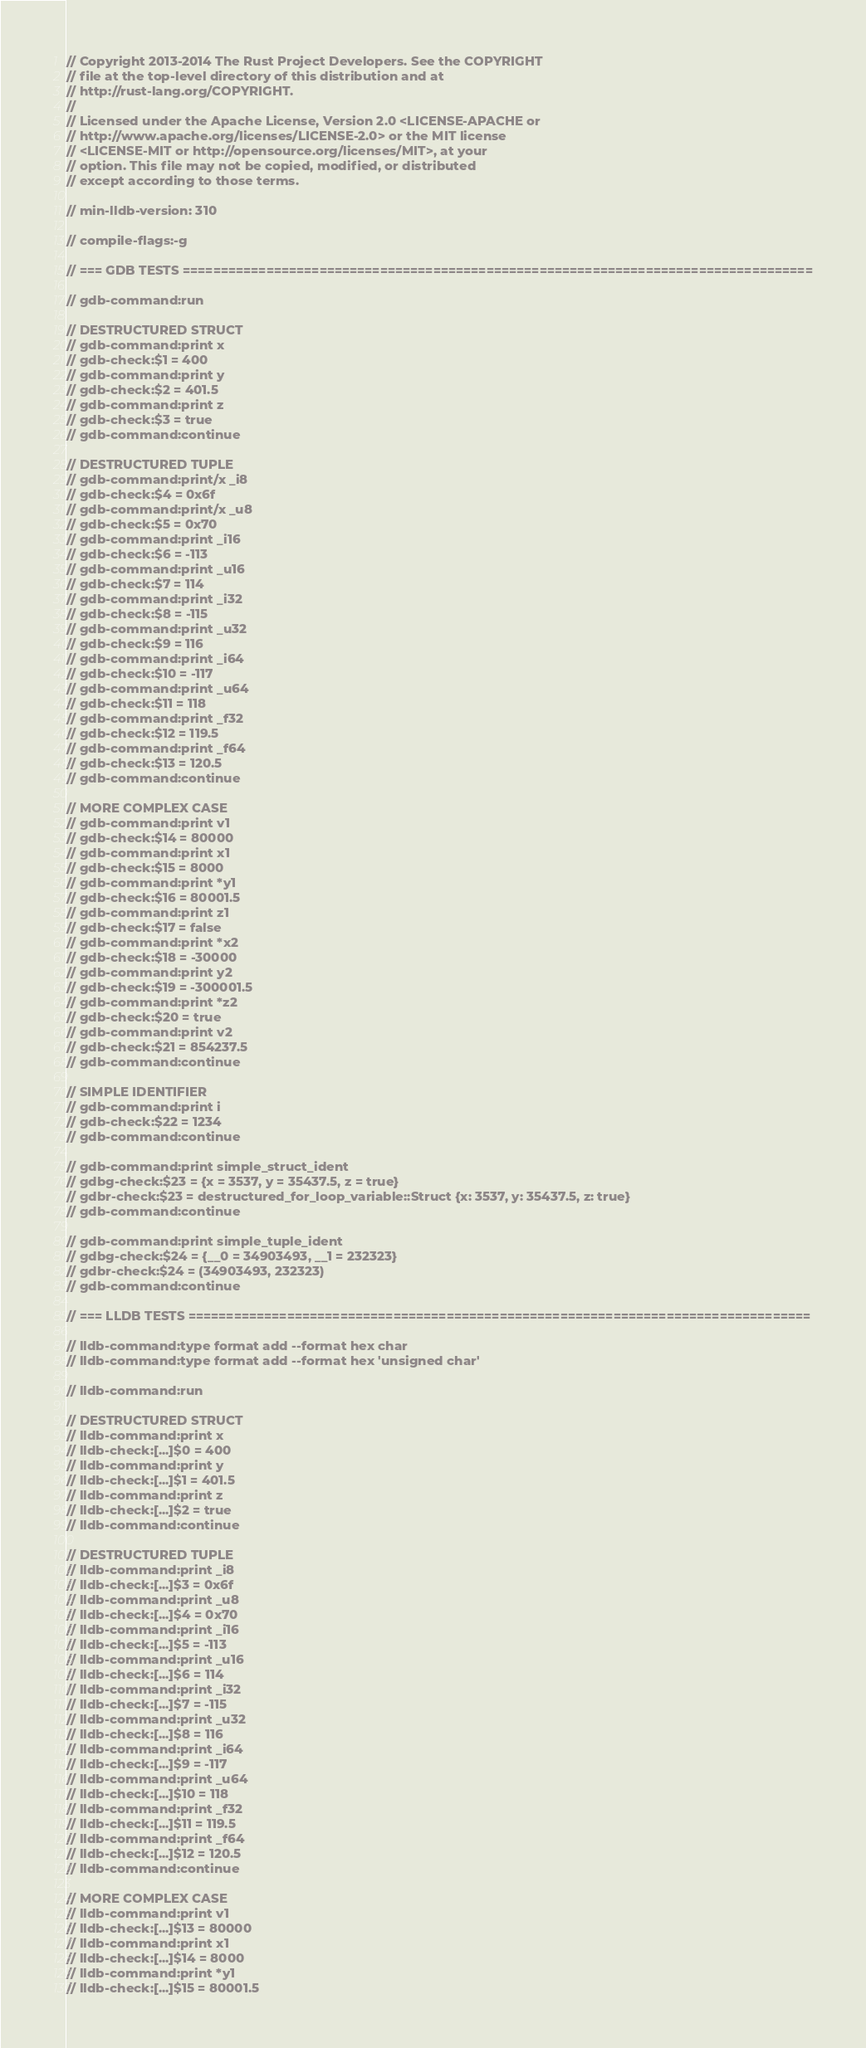Convert code to text. <code><loc_0><loc_0><loc_500><loc_500><_Rust_>// Copyright 2013-2014 The Rust Project Developers. See the COPYRIGHT
// file at the top-level directory of this distribution and at
// http://rust-lang.org/COPYRIGHT.
//
// Licensed under the Apache License, Version 2.0 <LICENSE-APACHE or
// http://www.apache.org/licenses/LICENSE-2.0> or the MIT license
// <LICENSE-MIT or http://opensource.org/licenses/MIT>, at your
// option. This file may not be copied, modified, or distributed
// except according to those terms.

// min-lldb-version: 310

// compile-flags:-g

// === GDB TESTS ===================================================================================

// gdb-command:run

// DESTRUCTURED STRUCT
// gdb-command:print x
// gdb-check:$1 = 400
// gdb-command:print y
// gdb-check:$2 = 401.5
// gdb-command:print z
// gdb-check:$3 = true
// gdb-command:continue

// DESTRUCTURED TUPLE
// gdb-command:print/x _i8
// gdb-check:$4 = 0x6f
// gdb-command:print/x _u8
// gdb-check:$5 = 0x70
// gdb-command:print _i16
// gdb-check:$6 = -113
// gdb-command:print _u16
// gdb-check:$7 = 114
// gdb-command:print _i32
// gdb-check:$8 = -115
// gdb-command:print _u32
// gdb-check:$9 = 116
// gdb-command:print _i64
// gdb-check:$10 = -117
// gdb-command:print _u64
// gdb-check:$11 = 118
// gdb-command:print _f32
// gdb-check:$12 = 119.5
// gdb-command:print _f64
// gdb-check:$13 = 120.5
// gdb-command:continue

// MORE COMPLEX CASE
// gdb-command:print v1
// gdb-check:$14 = 80000
// gdb-command:print x1
// gdb-check:$15 = 8000
// gdb-command:print *y1
// gdb-check:$16 = 80001.5
// gdb-command:print z1
// gdb-check:$17 = false
// gdb-command:print *x2
// gdb-check:$18 = -30000
// gdb-command:print y2
// gdb-check:$19 = -300001.5
// gdb-command:print *z2
// gdb-check:$20 = true
// gdb-command:print v2
// gdb-check:$21 = 854237.5
// gdb-command:continue

// SIMPLE IDENTIFIER
// gdb-command:print i
// gdb-check:$22 = 1234
// gdb-command:continue

// gdb-command:print simple_struct_ident
// gdbg-check:$23 = {x = 3537, y = 35437.5, z = true}
// gdbr-check:$23 = destructured_for_loop_variable::Struct {x: 3537, y: 35437.5, z: true}
// gdb-command:continue

// gdb-command:print simple_tuple_ident
// gdbg-check:$24 = {__0 = 34903493, __1 = 232323}
// gdbr-check:$24 = (34903493, 232323)
// gdb-command:continue

// === LLDB TESTS ==================================================================================

// lldb-command:type format add --format hex char
// lldb-command:type format add --format hex 'unsigned char'

// lldb-command:run

// DESTRUCTURED STRUCT
// lldb-command:print x
// lldb-check:[...]$0 = 400
// lldb-command:print y
// lldb-check:[...]$1 = 401.5
// lldb-command:print z
// lldb-check:[...]$2 = true
// lldb-command:continue

// DESTRUCTURED TUPLE
// lldb-command:print _i8
// lldb-check:[...]$3 = 0x6f
// lldb-command:print _u8
// lldb-check:[...]$4 = 0x70
// lldb-command:print _i16
// lldb-check:[...]$5 = -113
// lldb-command:print _u16
// lldb-check:[...]$6 = 114
// lldb-command:print _i32
// lldb-check:[...]$7 = -115
// lldb-command:print _u32
// lldb-check:[...]$8 = 116
// lldb-command:print _i64
// lldb-check:[...]$9 = -117
// lldb-command:print _u64
// lldb-check:[...]$10 = 118
// lldb-command:print _f32
// lldb-check:[...]$11 = 119.5
// lldb-command:print _f64
// lldb-check:[...]$12 = 120.5
// lldb-command:continue

// MORE COMPLEX CASE
// lldb-command:print v1
// lldb-check:[...]$13 = 80000
// lldb-command:print x1
// lldb-check:[...]$14 = 8000
// lldb-command:print *y1
// lldb-check:[...]$15 = 80001.5</code> 